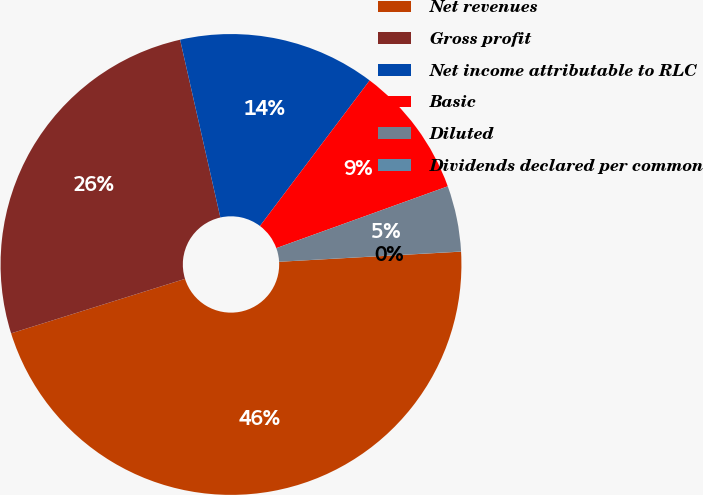<chart> <loc_0><loc_0><loc_500><loc_500><pie_chart><fcel>Net revenues<fcel>Gross profit<fcel>Net income attributable to RLC<fcel>Basic<fcel>Diluted<fcel>Dividends declared per common<nl><fcel>46.06%<fcel>26.29%<fcel>13.82%<fcel>9.22%<fcel>4.61%<fcel>0.01%<nl></chart> 